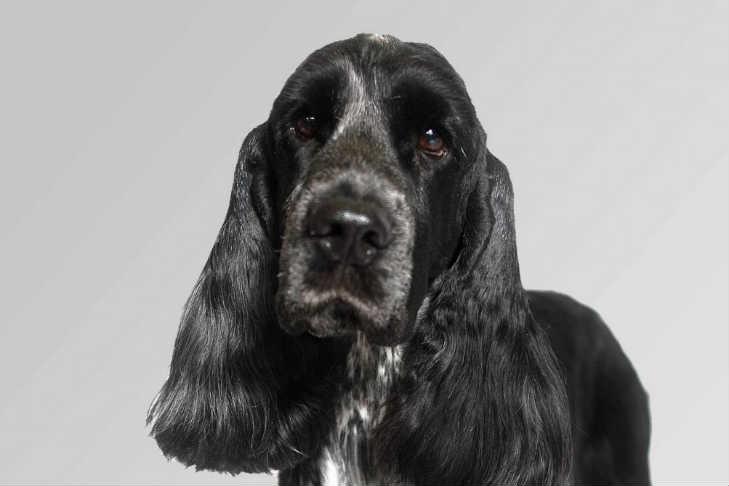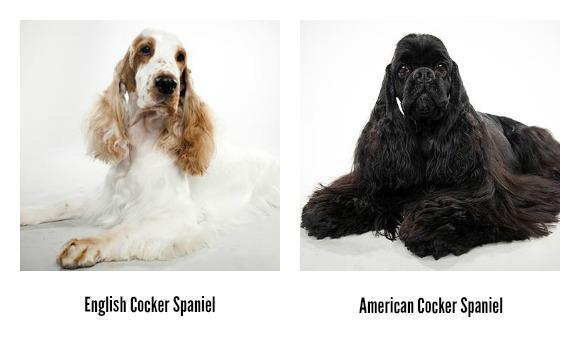The first image is the image on the left, the second image is the image on the right. Examine the images to the left and right. Is the description "There are no less than three dogs visible" accurate? Answer yes or no. Yes. 